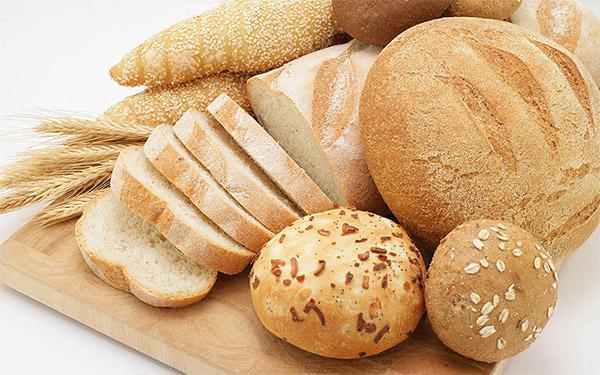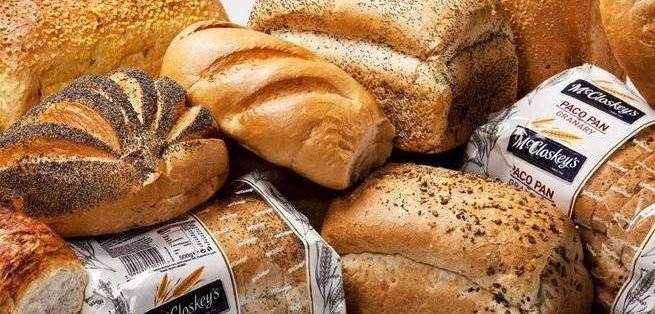The first image is the image on the left, the second image is the image on the right. Analyze the images presented: Is the assertion "Each image contains at least four different bread items, one image shows breads on unpainted wood, and no image includes unbaked dough." valid? Answer yes or no. Yes. The first image is the image on the left, the second image is the image on the right. Evaluate the accuracy of this statement regarding the images: "There are kitchen utensils visible in the right image.". Is it true? Answer yes or no. No. 